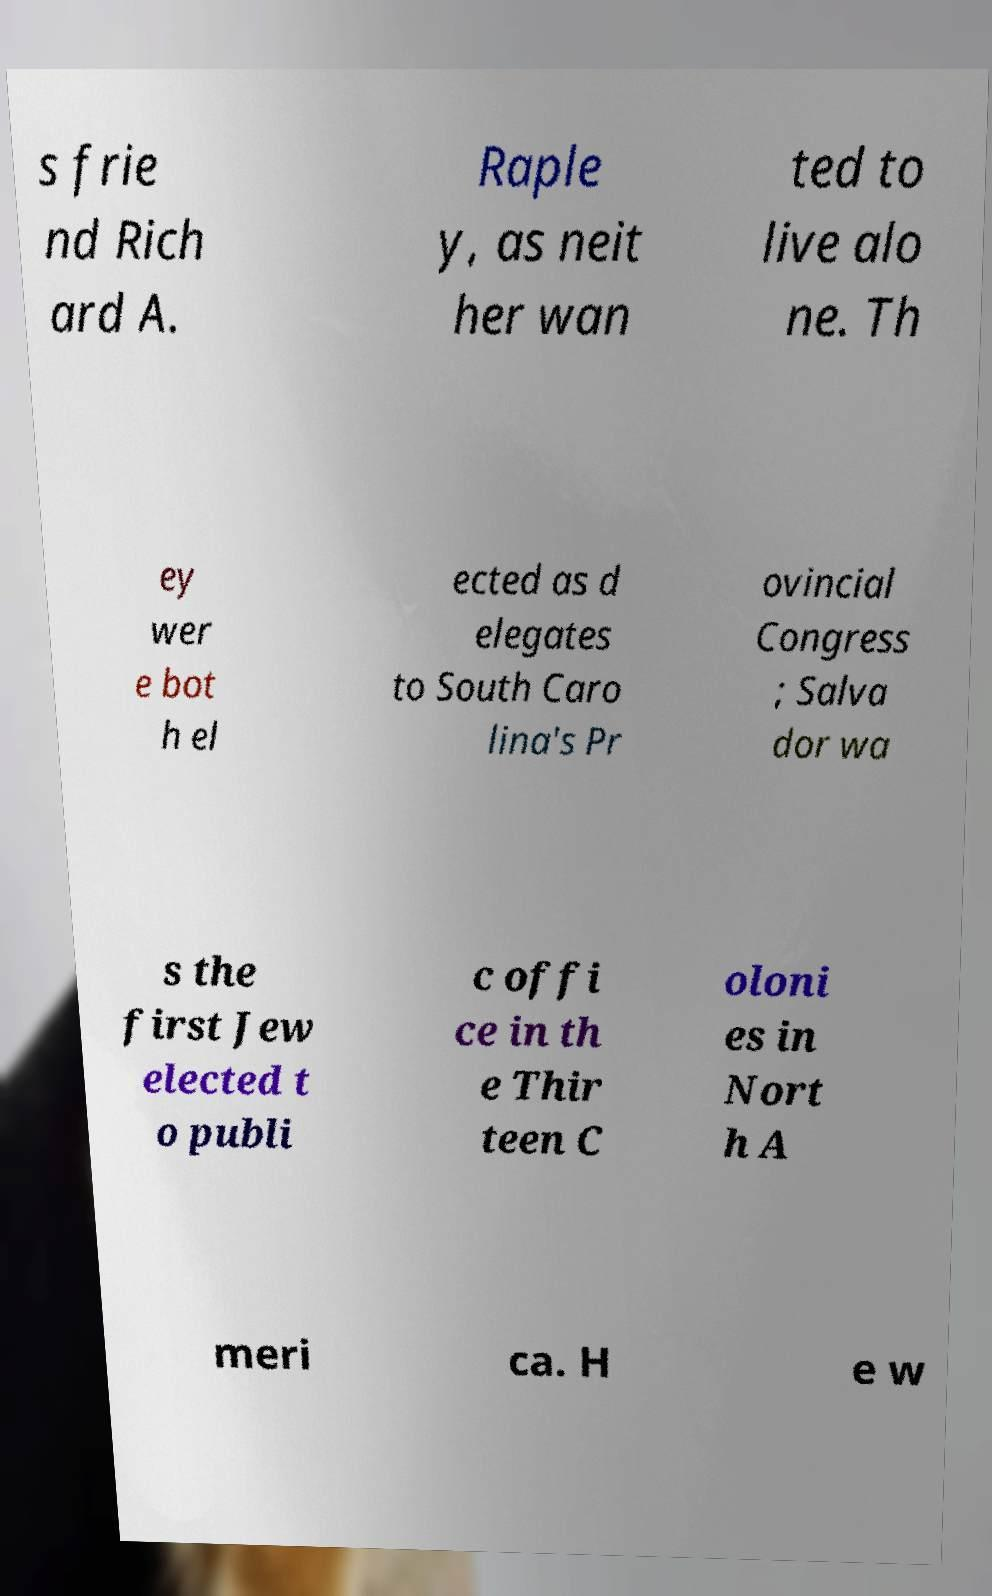For documentation purposes, I need the text within this image transcribed. Could you provide that? s frie nd Rich ard A. Raple y, as neit her wan ted to live alo ne. Th ey wer e bot h el ected as d elegates to South Caro lina's Pr ovincial Congress ; Salva dor wa s the first Jew elected t o publi c offi ce in th e Thir teen C oloni es in Nort h A meri ca. H e w 